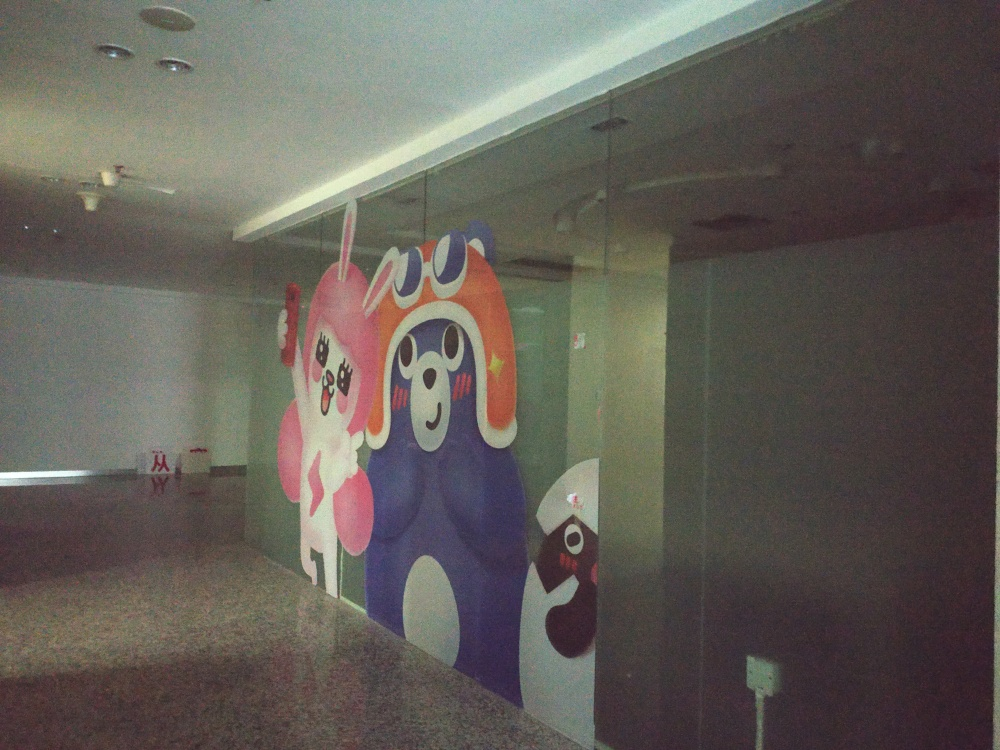How would you describe the texture and details of the advertising glass? The texture of the advertising glass appears to be smooth and glossy, typical of well-maintained glass surfaces. The details behind the glass, which are graphic designs with vibrant colors and playful characters, are visible yet subtly obscured due to the reflective quality of the glass surface. The clarity of the printed details is somewhat compromised by reflections and a lower level of light in the surrounding environment, giving an overall mediocre presentation when viewed through the glass. 